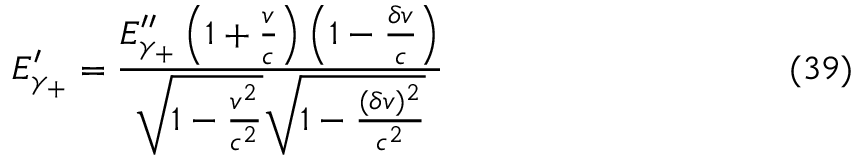<formula> <loc_0><loc_0><loc_500><loc_500>E _ { \gamma _ { + } } ^ { \prime } = \frac { E _ { \gamma _ { + } } ^ { \prime \prime } \left ( 1 + \frac { v } { c } \right ) \left ( 1 - \frac { \delta v } { c } \right ) } { \sqrt { 1 - \frac { v ^ { 2 } } { c ^ { 2 } } } \sqrt { 1 - \frac { ( \delta v ) ^ { 2 } } { c ^ { 2 } } } } \ e q n o ( 3 9 )</formula> 